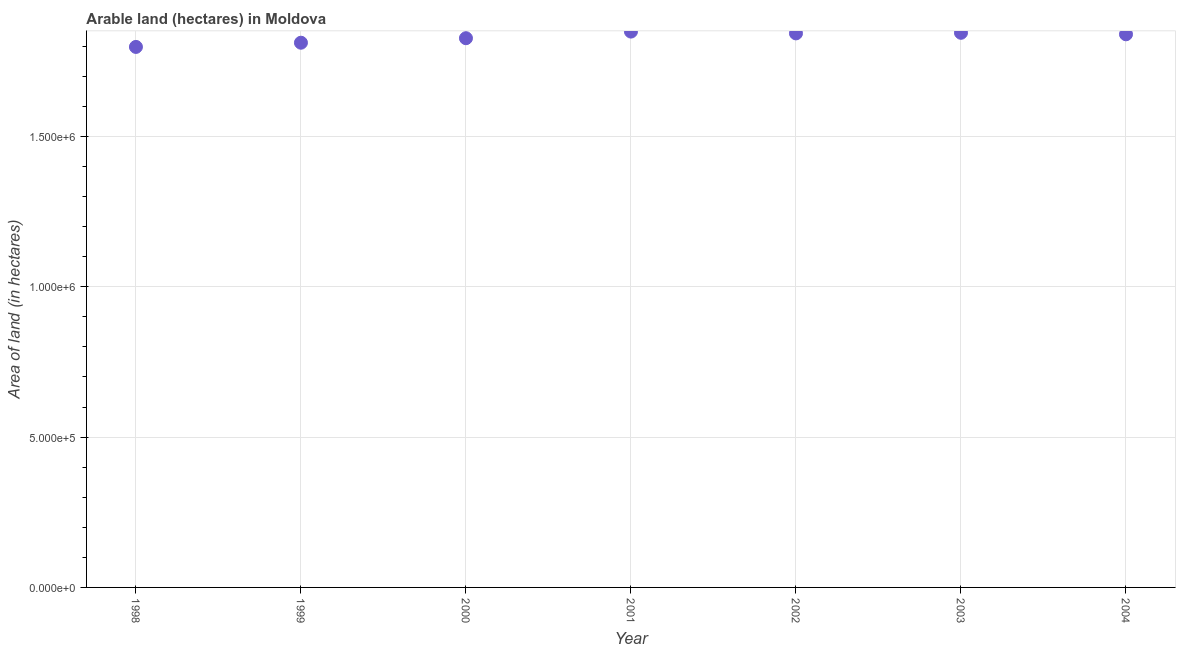What is the area of land in 2001?
Provide a short and direct response. 1.85e+06. Across all years, what is the maximum area of land?
Your answer should be very brief. 1.85e+06. Across all years, what is the minimum area of land?
Provide a short and direct response. 1.80e+06. In which year was the area of land minimum?
Your answer should be compact. 1998. What is the sum of the area of land?
Your answer should be compact. 1.28e+07. What is the difference between the area of land in 2000 and 2001?
Your response must be concise. -2.20e+04. What is the average area of land per year?
Your answer should be very brief. 1.83e+06. What is the median area of land?
Keep it short and to the point. 1.84e+06. In how many years, is the area of land greater than 200000 hectares?
Your response must be concise. 7. Do a majority of the years between 2001 and 1999 (inclusive) have area of land greater than 500000 hectares?
Your response must be concise. No. What is the ratio of the area of land in 2000 to that in 2004?
Make the answer very short. 0.99. Is the area of land in 2000 less than that in 2004?
Provide a succinct answer. Yes. What is the difference between the highest and the second highest area of land?
Keep it short and to the point. 4000. What is the difference between the highest and the lowest area of land?
Provide a succinct answer. 5.10e+04. How many dotlines are there?
Keep it short and to the point. 1. How many years are there in the graph?
Make the answer very short. 7. Does the graph contain any zero values?
Provide a succinct answer. No. Does the graph contain grids?
Offer a very short reply. Yes. What is the title of the graph?
Keep it short and to the point. Arable land (hectares) in Moldova. What is the label or title of the Y-axis?
Your answer should be compact. Area of land (in hectares). What is the Area of land (in hectares) in 1998?
Offer a very short reply. 1.80e+06. What is the Area of land (in hectares) in 1999?
Your answer should be very brief. 1.81e+06. What is the Area of land (in hectares) in 2000?
Offer a very short reply. 1.83e+06. What is the Area of land (in hectares) in 2001?
Your response must be concise. 1.85e+06. What is the Area of land (in hectares) in 2002?
Offer a terse response. 1.84e+06. What is the Area of land (in hectares) in 2003?
Keep it short and to the point. 1.84e+06. What is the Area of land (in hectares) in 2004?
Your response must be concise. 1.84e+06. What is the difference between the Area of land (in hectares) in 1998 and 1999?
Provide a succinct answer. -1.40e+04. What is the difference between the Area of land (in hectares) in 1998 and 2000?
Make the answer very short. -2.90e+04. What is the difference between the Area of land (in hectares) in 1998 and 2001?
Your answer should be very brief. -5.10e+04. What is the difference between the Area of land (in hectares) in 1998 and 2002?
Offer a very short reply. -4.50e+04. What is the difference between the Area of land (in hectares) in 1998 and 2003?
Offer a very short reply. -4.70e+04. What is the difference between the Area of land (in hectares) in 1998 and 2004?
Keep it short and to the point. -4.20e+04. What is the difference between the Area of land (in hectares) in 1999 and 2000?
Provide a short and direct response. -1.50e+04. What is the difference between the Area of land (in hectares) in 1999 and 2001?
Keep it short and to the point. -3.70e+04. What is the difference between the Area of land (in hectares) in 1999 and 2002?
Keep it short and to the point. -3.10e+04. What is the difference between the Area of land (in hectares) in 1999 and 2003?
Keep it short and to the point. -3.30e+04. What is the difference between the Area of land (in hectares) in 1999 and 2004?
Your response must be concise. -2.80e+04. What is the difference between the Area of land (in hectares) in 2000 and 2001?
Offer a terse response. -2.20e+04. What is the difference between the Area of land (in hectares) in 2000 and 2002?
Keep it short and to the point. -1.60e+04. What is the difference between the Area of land (in hectares) in 2000 and 2003?
Your answer should be compact. -1.80e+04. What is the difference between the Area of land (in hectares) in 2000 and 2004?
Your answer should be very brief. -1.30e+04. What is the difference between the Area of land (in hectares) in 2001 and 2002?
Ensure brevity in your answer.  6000. What is the difference between the Area of land (in hectares) in 2001 and 2003?
Offer a terse response. 4000. What is the difference between the Area of land (in hectares) in 2001 and 2004?
Provide a succinct answer. 9000. What is the difference between the Area of land (in hectares) in 2002 and 2003?
Your answer should be very brief. -2000. What is the difference between the Area of land (in hectares) in 2002 and 2004?
Offer a very short reply. 3000. What is the difference between the Area of land (in hectares) in 2003 and 2004?
Offer a terse response. 5000. What is the ratio of the Area of land (in hectares) in 1998 to that in 2000?
Make the answer very short. 0.98. What is the ratio of the Area of land (in hectares) in 1999 to that in 2001?
Make the answer very short. 0.98. What is the ratio of the Area of land (in hectares) in 1999 to that in 2004?
Provide a short and direct response. 0.98. What is the ratio of the Area of land (in hectares) in 2000 to that in 2003?
Offer a very short reply. 0.99. What is the ratio of the Area of land (in hectares) in 2001 to that in 2002?
Keep it short and to the point. 1. What is the ratio of the Area of land (in hectares) in 2001 to that in 2003?
Your answer should be very brief. 1. What is the ratio of the Area of land (in hectares) in 2001 to that in 2004?
Keep it short and to the point. 1. What is the ratio of the Area of land (in hectares) in 2002 to that in 2003?
Give a very brief answer. 1. 